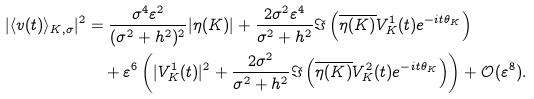Convert formula to latex. <formula><loc_0><loc_0><loc_500><loc_500>| \langle v ( t ) \rangle _ { K , \sigma } | ^ { 2 } & = \frac { \sigma ^ { 4 } \varepsilon ^ { 2 } } { ( \sigma ^ { 2 } + h ^ { 2 } ) ^ { 2 } } | \eta ( K ) | + \frac { 2 \sigma ^ { 2 } \varepsilon ^ { 4 } } { \sigma ^ { 2 } + h ^ { 2 } } \Im \left ( \overline { \eta ( K ) } V _ { K } ^ { 1 } ( t ) e ^ { - i t \theta _ { K } } \right ) \\ & \quad + \varepsilon ^ { 6 } \left ( | V _ { K } ^ { 1 } ( t ) | ^ { 2 } + \frac { 2 \sigma ^ { 2 } } { \sigma ^ { 2 } + h ^ { 2 } } \Im \left ( \overline { \eta ( K ) } V _ { K } ^ { 2 } ( t ) e ^ { - i t \theta _ { K } } \right ) \right ) + \mathcal { O } ( \varepsilon ^ { 8 } ) .</formula> 